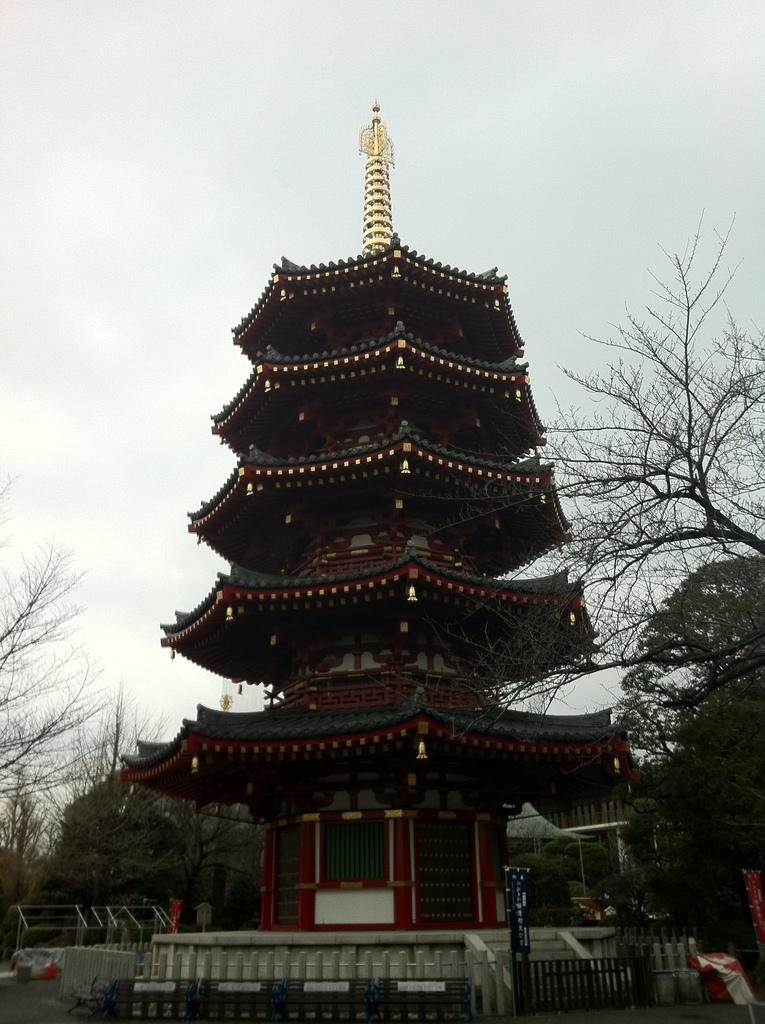What type of structure is present in the image? There is a building in the image. What can be seen near the building? There are trees near the building. Are there any architectural features visible in the image? Yes, there are railings in the image. What is visible in the background of the image? The sky is visible in the background of the image. Can you see a bear holding a flower in the image? No, there is no bear or flower present in the image. 